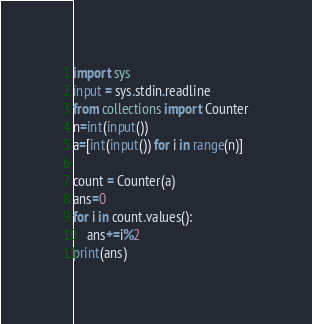<code> <loc_0><loc_0><loc_500><loc_500><_Python_>import sys
input = sys.stdin.readline
from collections import Counter
n=int(input())
a=[int(input()) for i in range(n)]

count = Counter(a)
ans=0
for i in count.values():
    ans+=i%2
print(ans)</code> 